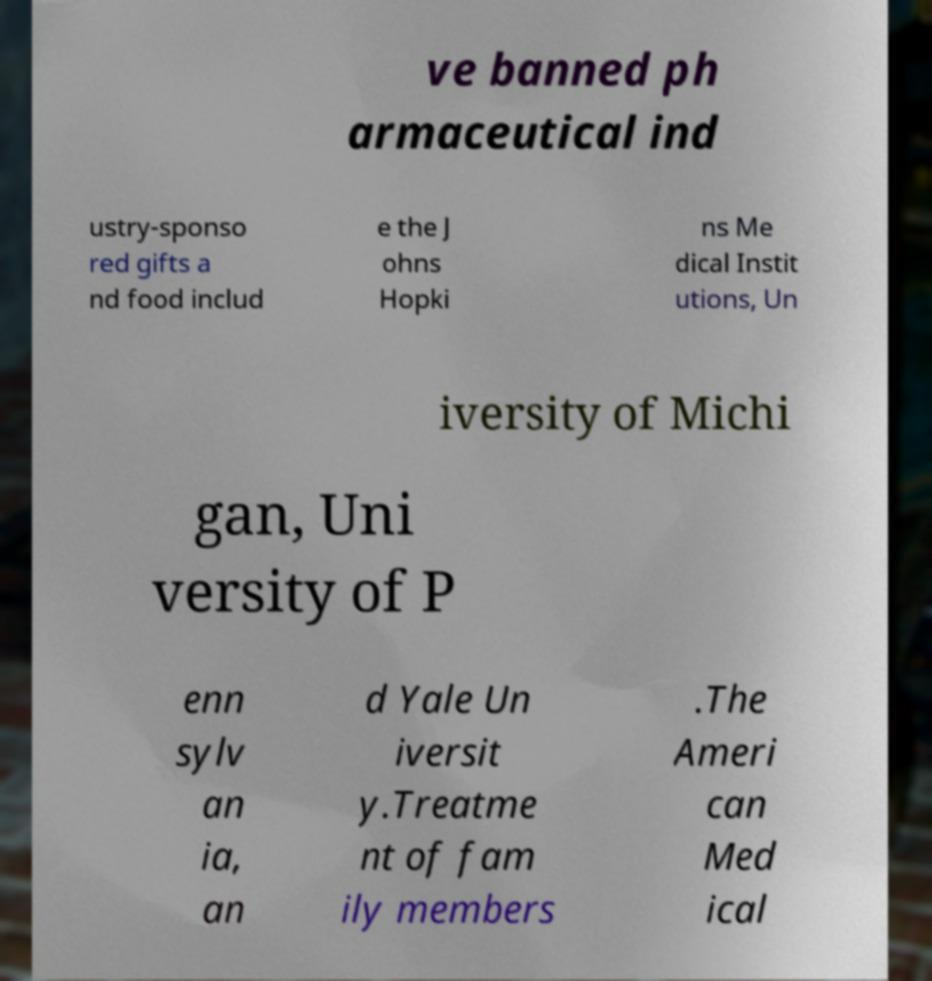For documentation purposes, I need the text within this image transcribed. Could you provide that? ve banned ph armaceutical ind ustry-sponso red gifts a nd food includ e the J ohns Hopki ns Me dical Instit utions, Un iversity of Michi gan, Uni versity of P enn sylv an ia, an d Yale Un iversit y.Treatme nt of fam ily members .The Ameri can Med ical 